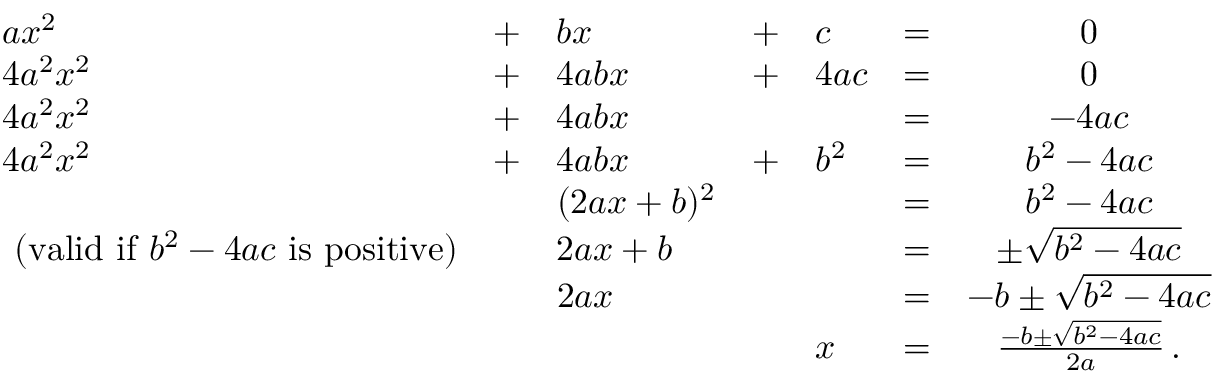Convert formula to latex. <formula><loc_0><loc_0><loc_500><loc_500>{ \begin{array} { l l l l l l c } { a x ^ { 2 } } & { + } & { b x } & { + } & { c } & { = } & { 0 } \\ { 4 a ^ { 2 } x ^ { 2 } } & { + } & { 4 a b x } & { + } & { 4 a c } & { = } & { 0 } \\ { 4 a ^ { 2 } x ^ { 2 } } & { + } & { 4 a b x } & & & { = } & { - 4 a c } \\ { 4 a ^ { 2 } x ^ { 2 } } & { + } & { 4 a b x } & { + } & { b ^ { 2 } } & { = } & { b ^ { 2 } - 4 a c } \\ & & { ( 2 a x + b ) ^ { 2 } } & & & { = } & { b ^ { 2 } - 4 a c } \\ { { ( v a l i d i f } b ^ { 2 } - 4 a c { i s p o s i t i v e ) } } & & { 2 a x + b } & & & { = } & { \pm { \sqrt { b ^ { 2 } - 4 a c } } } \\ & & { 2 a x } & & & { = } & { - b \pm { \sqrt { b ^ { 2 } - 4 a c } } } \\ & & & & { x } & { = } & { { \frac { - b \pm { \sqrt { b ^ { 2 } - 4 a c } } } { 2 a } } \, . } \\ { \, } \end{array} }</formula> 